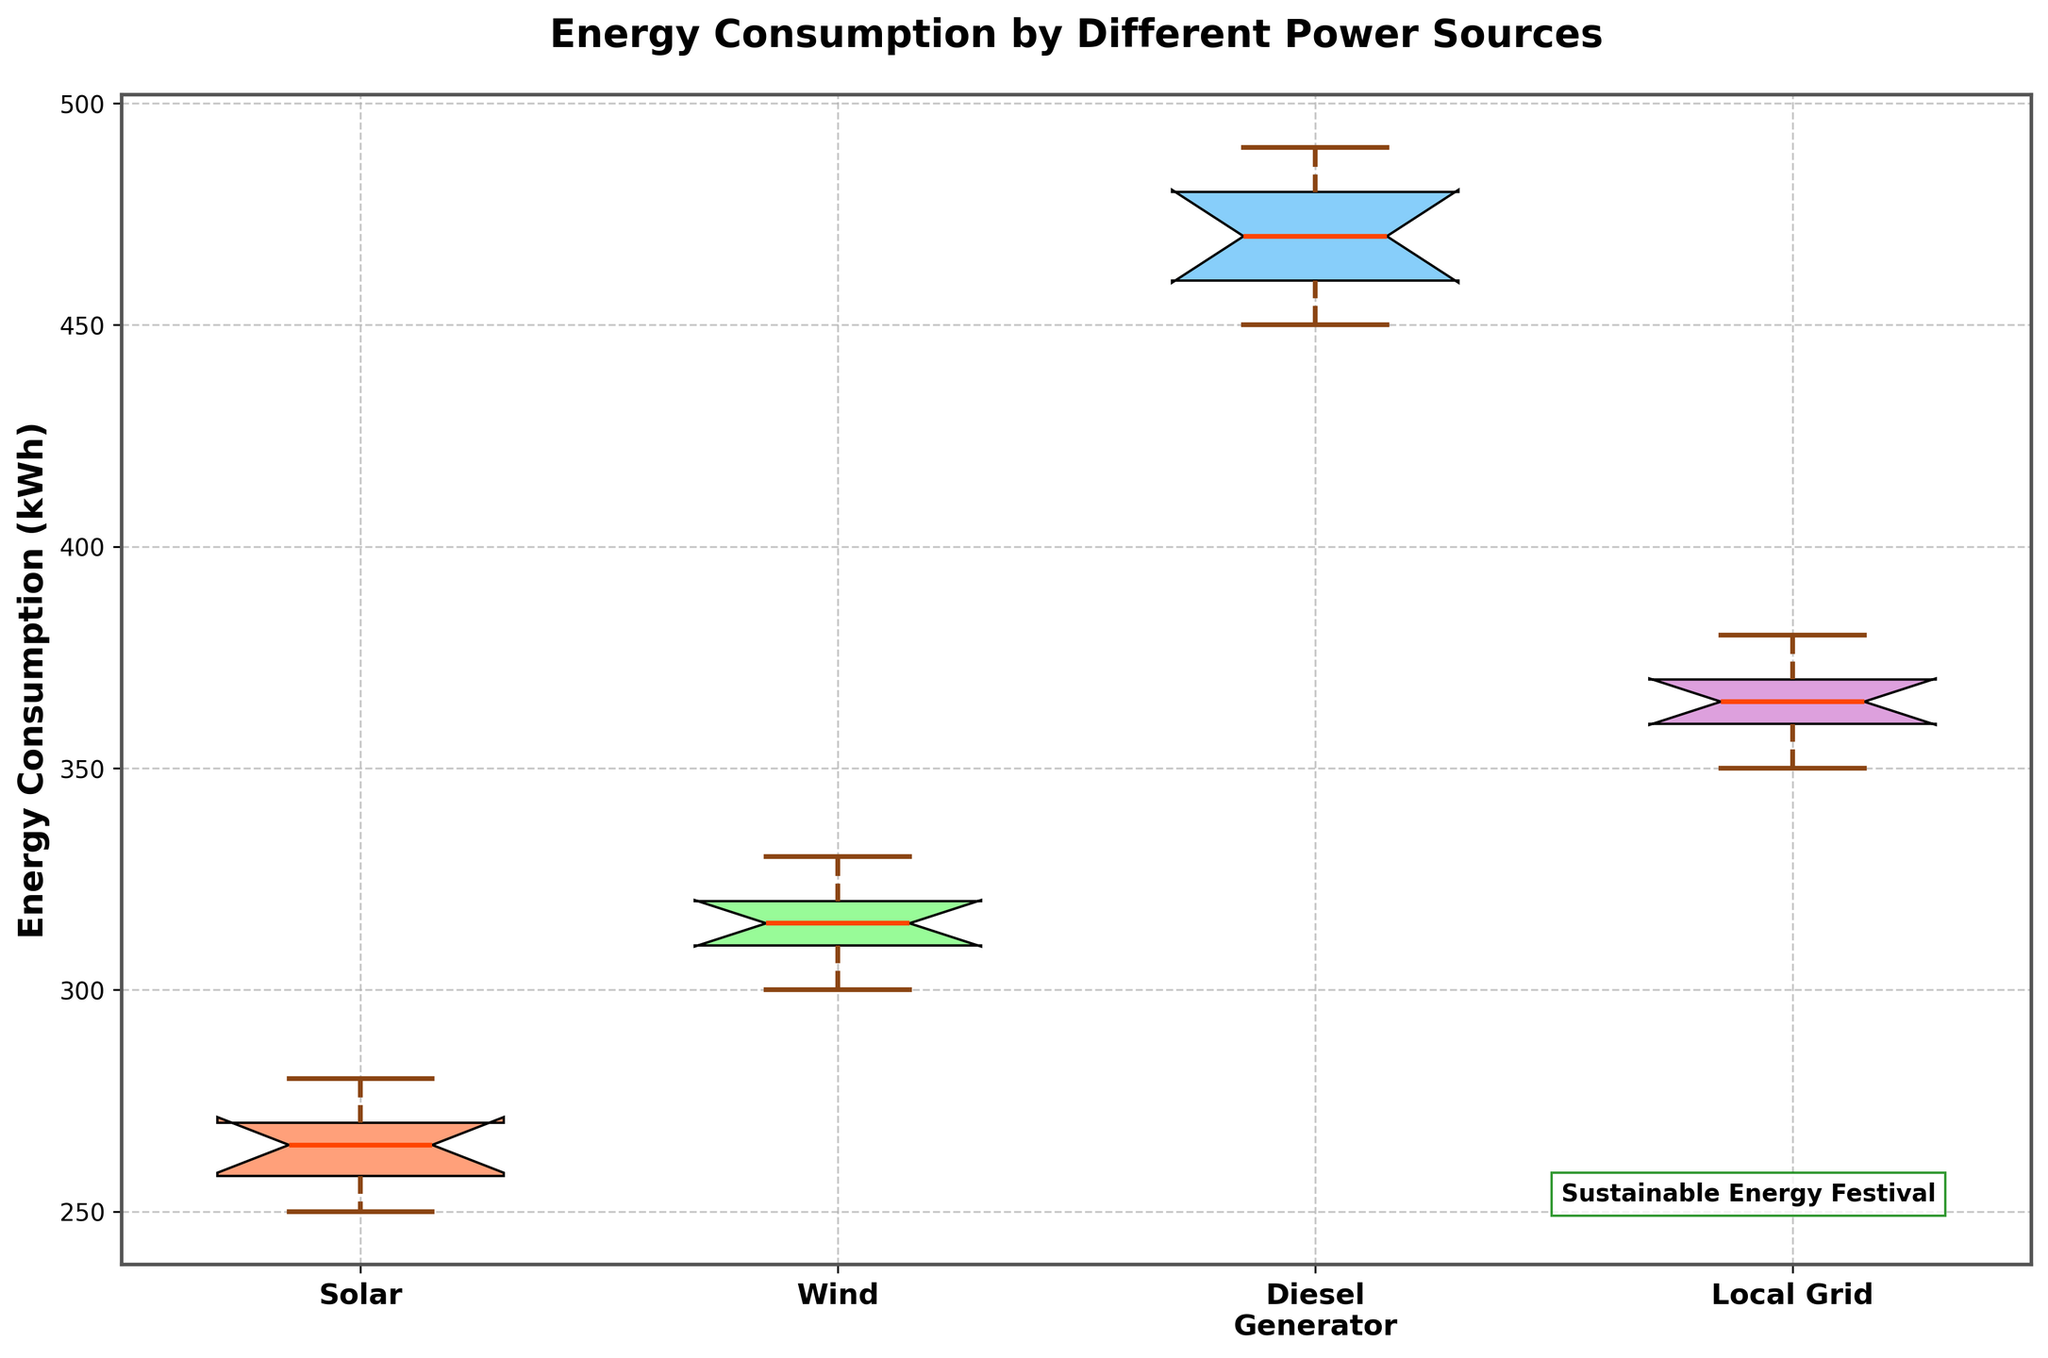What is the title of the figure? The title of the figure is located at the top of the plot in bold text.
Answer: Energy Consumption by Different Power Sources Which power source has the highest energy consumption median? The median is represented by the thick solid line within each box. By comparing the medians of the notched box plots, the Diesel Generator has the highest median.
Answer: Diesel Generator How many power sources are compared in this figure? The x-axis labels represent the different power sources. There are four distinct labels on the x-axis.
Answer: Four What color represents the Solar power source in the figure? The colors for each power source are seen in the filled boxes. The Solar power source is represented by the color matching the first box from the left.
Answer: Light Salmon What is the range of energy consumption values for the Wind power source? The range is determined by the whiskers, which extend from the lower to upper adjacent values. For Wind power, this extends from 300 kWh to 330 kWh.
Answer: 300 kWh - 330 kWh Which power source shows the most variability in energy consumption? Variability can be assessed by the interquartile range (IQR), which is the length of the box. The Diesel Generator has the widest box, indicating the most variability.
Answer: Diesel Generator Are there any outliers for the Local Grid power source? Outliers in the box plot are indicated by data points that fall outside the whiskers. For the Local Grid, there are no data points outside the whiskers.
Answer: No What visual elements indicate the median energy consumption for each power source? The median energy consumption is marked by the thick solid line within the boxes of each notched box plot.
Answer: Thick solid lines inside the boxes Which power source has the smallest interquartile range (IQR)? The smallest IQR is determined by the box with the shortest vertical height. The Solar power source has the smallest IQR.
Answer: Solar Does any power source have overlapping notches with another, and what does this indicate? Overlapping notches in box plots suggest that the medians are not significantly different. The notches for Solar and Wind overlap slightly, indicating similar medians.
Answer: Yes, Solar and Wind 